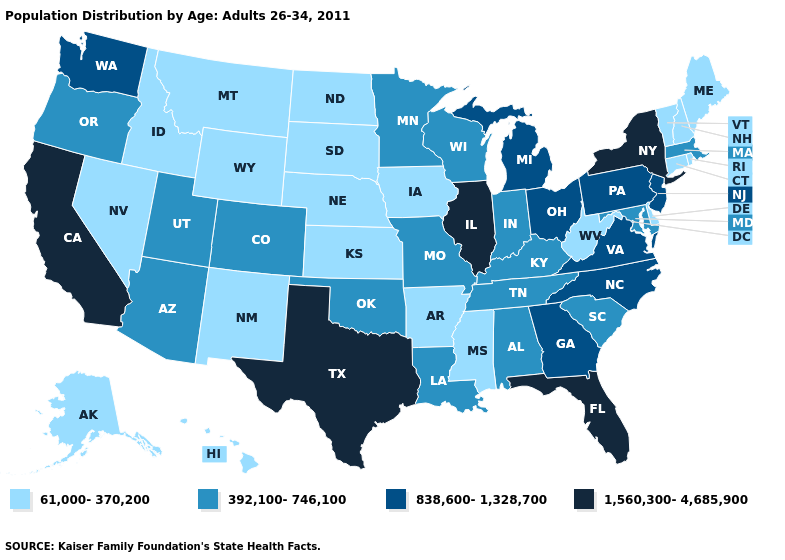What is the highest value in the MidWest ?
Quick response, please. 1,560,300-4,685,900. Does the map have missing data?
Quick response, please. No. Which states have the lowest value in the USA?
Give a very brief answer. Alaska, Arkansas, Connecticut, Delaware, Hawaii, Idaho, Iowa, Kansas, Maine, Mississippi, Montana, Nebraska, Nevada, New Hampshire, New Mexico, North Dakota, Rhode Island, South Dakota, Vermont, West Virginia, Wyoming. What is the value of Missouri?
Write a very short answer. 392,100-746,100. Which states have the lowest value in the USA?
Concise answer only. Alaska, Arkansas, Connecticut, Delaware, Hawaii, Idaho, Iowa, Kansas, Maine, Mississippi, Montana, Nebraska, Nevada, New Hampshire, New Mexico, North Dakota, Rhode Island, South Dakota, Vermont, West Virginia, Wyoming. What is the highest value in the USA?
Give a very brief answer. 1,560,300-4,685,900. Name the states that have a value in the range 838,600-1,328,700?
Concise answer only. Georgia, Michigan, New Jersey, North Carolina, Ohio, Pennsylvania, Virginia, Washington. What is the lowest value in the West?
Concise answer only. 61,000-370,200. Does Texas have a lower value than Illinois?
Be succinct. No. What is the value of Pennsylvania?
Be succinct. 838,600-1,328,700. Is the legend a continuous bar?
Give a very brief answer. No. What is the lowest value in the USA?
Concise answer only. 61,000-370,200. Name the states that have a value in the range 392,100-746,100?
Give a very brief answer. Alabama, Arizona, Colorado, Indiana, Kentucky, Louisiana, Maryland, Massachusetts, Minnesota, Missouri, Oklahoma, Oregon, South Carolina, Tennessee, Utah, Wisconsin. What is the highest value in states that border Florida?
Short answer required. 838,600-1,328,700. Is the legend a continuous bar?
Quick response, please. No. 